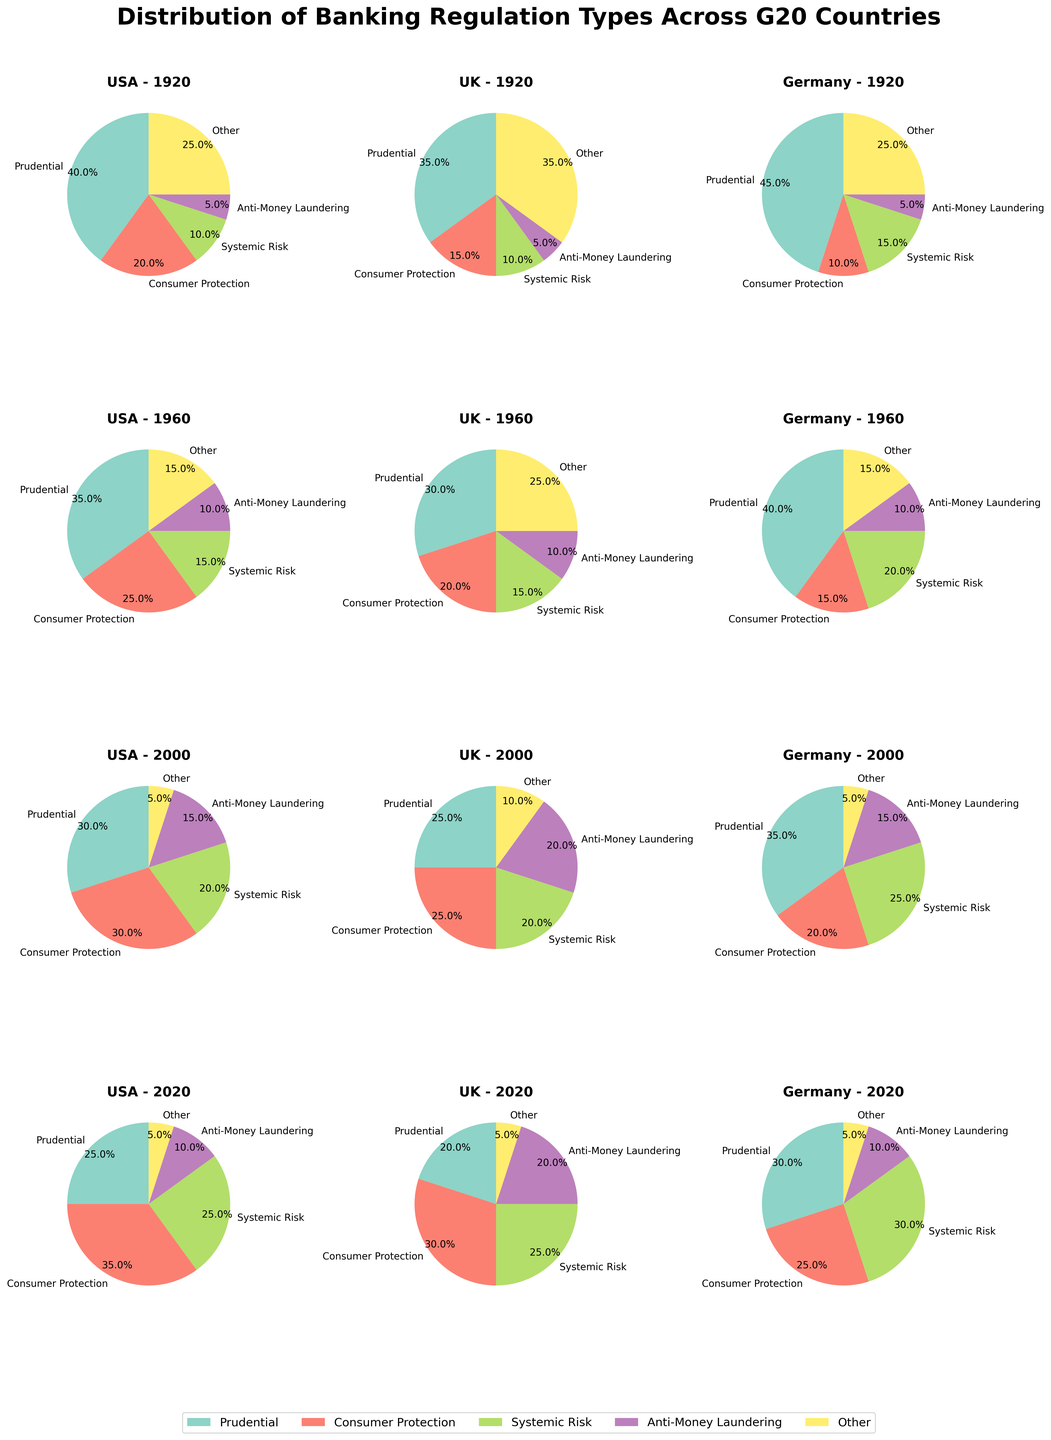What percentage of banking regulation in the USA in 2000 was dedicated to systemic risk? Examine the slice of the pie chart for the USA in the year 2000 labeled "Systemic Risk." The label shows the percentage of 20%.
Answer: 20% Which country had the highest percentage of consumer protection regulation in 2020? Compare the consumer protection slice in the 2020 pie charts for the USA, UK, and Germany. The USA has 35%, the UK has 30%, and Germany has 25%. The highest percentage is in the USA.
Answer: USA How did the percentage of prudential regulation in Germany change from 1920 to 2020? Look at the prudential regulation slices for Germany in 1920 and 2020. In 1920 it is 45%, and in 2020 it is 30%. The change is 45% - 30% = 15% decrease.
Answer: Decreased by 15% Which years show an equal distribution of "Other" regulation type among all three countries? Look at the slice labeled "Other" in all years for USA, UK, and Germany. In 2000, all countries (USA, UK, Germany) have "Other" regulation type as 5%.
Answer: 2000 What was the largest percentage category for the UK in 1960? Observe the pie chart for the UK in 1960 to identify the largest slice. The largest category is "Other" at 25%.
Answer: Other Compare the change in the percentage of AML (Anti-Money Laundering) regulation in the USA from 1920 to 2020 and in the UK from 1920 to 2020. Which country saw a greater increase? Look at the AML regulation percentages for the USA and UK in 1920 and 2020. USA: 1920 = 5%, 2020 = 10% (5% increase). UK: 1920 = 5%, 2020 = 20% (15% increase). The UK saw a greater increase.
Answer: UK What is the sum of the percentages for prudential and systemic risk regulations in Germany for 2000? Add the percentages for "Prudential" and "Systemic Risk" in Germany for the year 2000. Prudential = 35%, Systemic Risk = 25%. The sum is 35% + 25% = 60%.
Answer: 60% Identify the year in which consumer protection regulation gained the highest percentage increase in the USA from its previous value. Compare percentage values of "Consumer Protection" in the USA across all years. From 1920 to 1960: 20% to 25% (5% increase). From 1960 to 2000: 25% to 30% (5% increase). From 2000 to 2020: 30% to 35% (largest increase of 5%). The largest increase is consistent but reaches its peak in 2020.
Answer: 2020 Between Germany and the UK, which country had a greater focus on systemic risk regulation in 2000? Compare the percentage of "Systemic Risk" regulation in Germany and the UK for 2000. Germany has 25%, and the UK has 20%. Germany has a greater focus.
Answer: Germany 